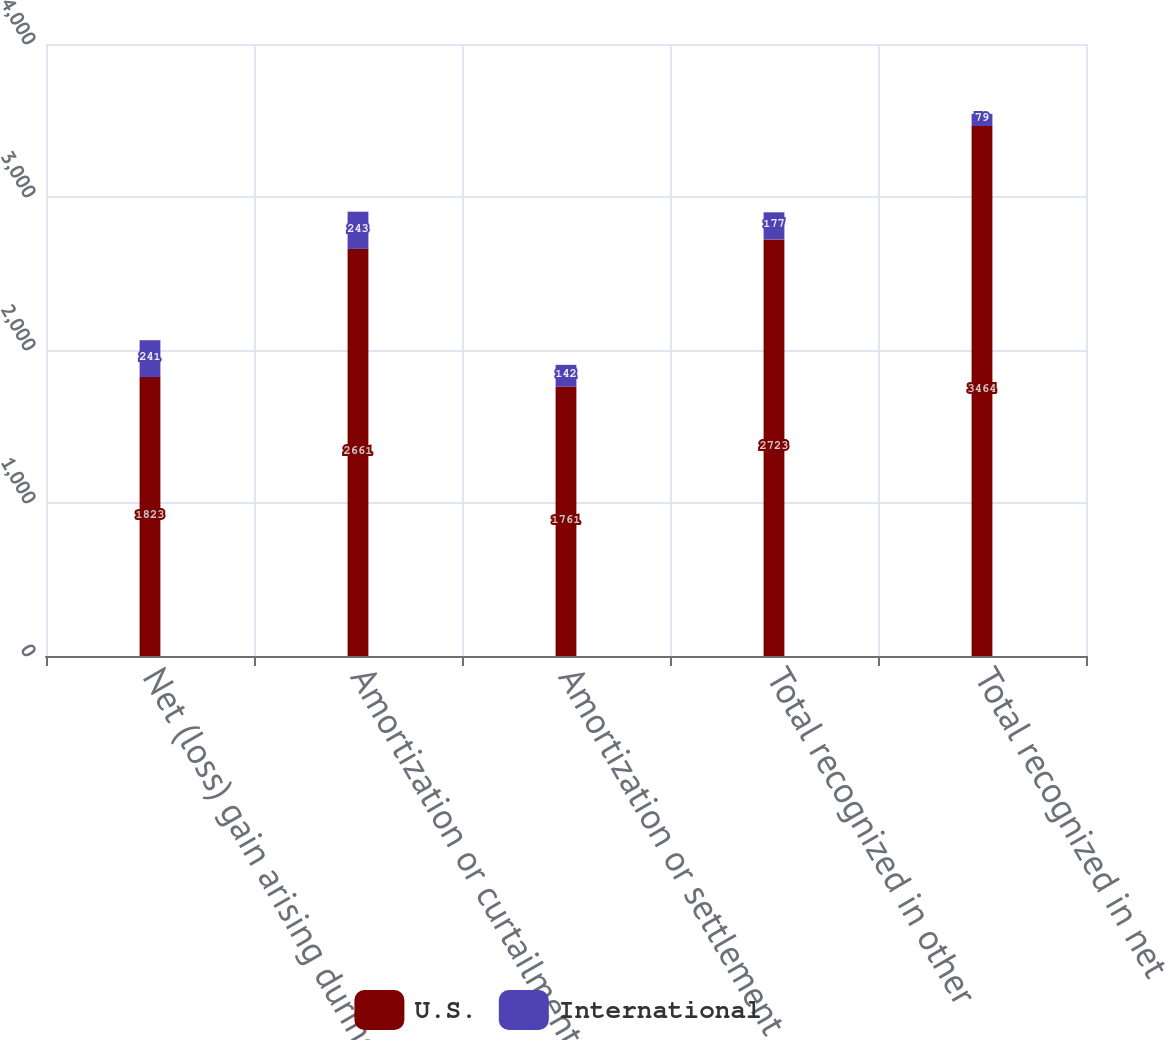Convert chart to OTSL. <chart><loc_0><loc_0><loc_500><loc_500><stacked_bar_chart><ecel><fcel>Net (loss) gain arising during<fcel>Amortization or curtailment<fcel>Amortization or settlement<fcel>Total recognized in other<fcel>Total recognized in net<nl><fcel>U.S.<fcel>1823<fcel>2661<fcel>1761<fcel>2723<fcel>3464<nl><fcel>International<fcel>241<fcel>243<fcel>142<fcel>177<fcel>79<nl></chart> 